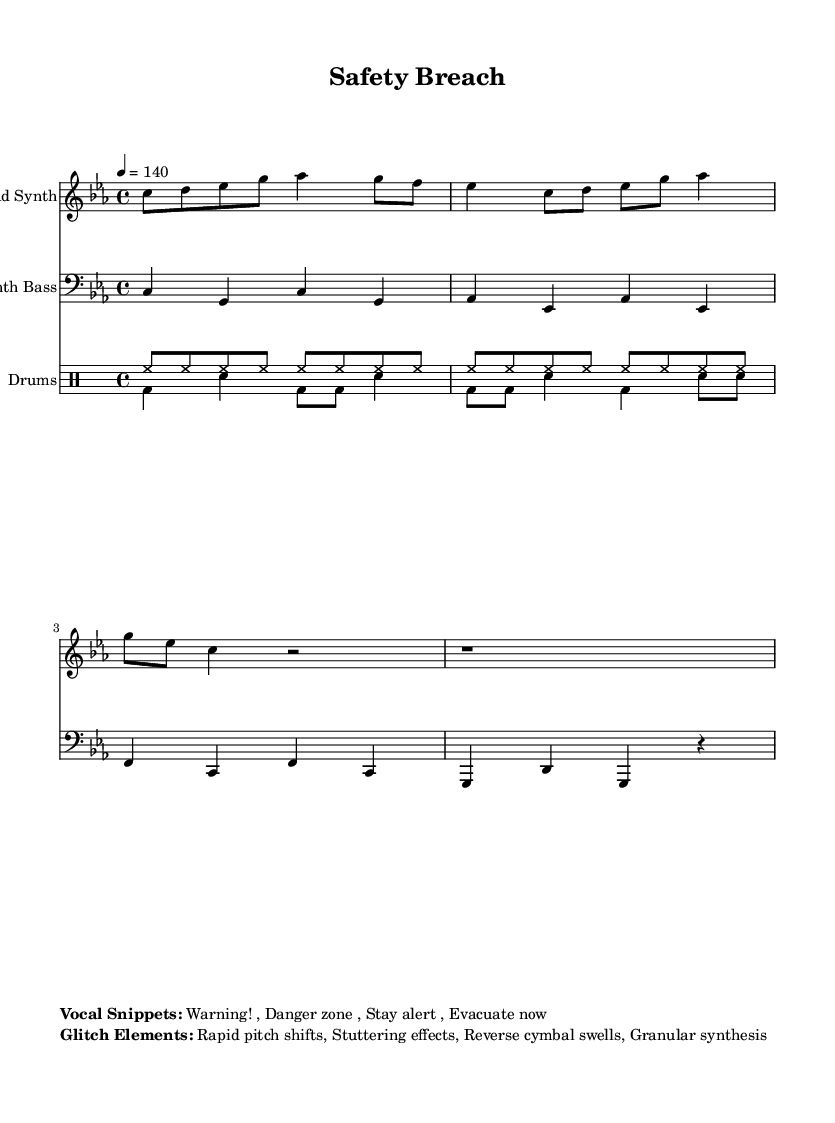What is the key signature of this music? The key signature shows that this piece is in C minor, which has three flats (B♭, E♭, A♭). This can be identified in the key signature section of the sheet music.
Answer: C minor What is the time signature? The time signature is 4/4, indicating that there are four beats per measure. This is specified at the beginning of the music, clearly stated in the time signature section.
Answer: 4/4 What is the tempo marking? The tempo marking indicates that the piece should be played at 140 beats per minute. This is found in the tempo section of the score.
Answer: 140 How many vocal snippets are listed? There are four vocal snippets listed below the music. By counting the phrases provided in the vocal snippets section, you can determine the total.
Answer: 4 Describe one glitch element from the sheet music. The sheet music lists "Granular synthesis" as one of the glitch elements. This element can be found in the section that outlines the glitch characteristics of the piece.
Answer: Granular synthesis Which instrument plays the lead part? The lead part is played by the Lead Synth, which is specified at the top of the staff where the lead part is notated.
Answer: Lead Synth What is the rhythmic pattern of the hi-hat? The hi-hat pattern consists of eight eighth notes in each measure, which is displayed in the drummode section for the upbeats. You can identify this by looking for the notation of the hi-hat throughout the score.
Answer: Eight eighth notes 